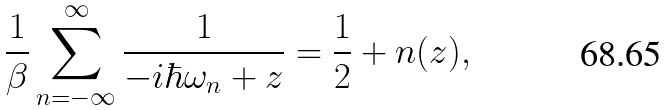<formula> <loc_0><loc_0><loc_500><loc_500>\frac { 1 } { \beta } \sum _ { n = - \infty } ^ { \infty } \frac { 1 } { - i \hbar { \omega } _ { n } + z } = \frac { 1 } { 2 } + n ( z ) ,</formula> 